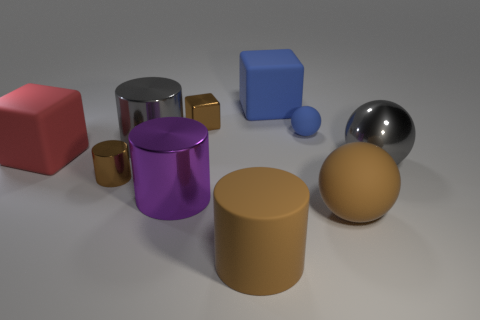Subtract 1 cylinders. How many cylinders are left? 3 Subtract all spheres. How many objects are left? 7 Add 4 small blue spheres. How many small blue spheres exist? 5 Subtract 0 green balls. How many objects are left? 10 Subtract all tiny metallic blocks. Subtract all large rubber cubes. How many objects are left? 7 Add 2 rubber cylinders. How many rubber cylinders are left? 3 